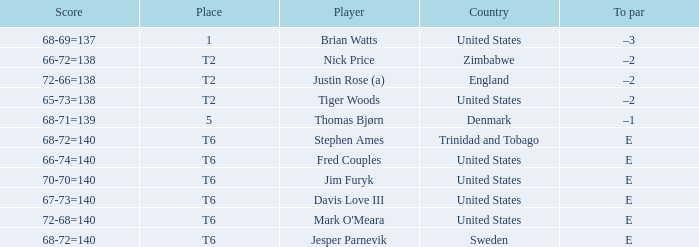What was the TO par for the player who scored 68-71=139? –1. 